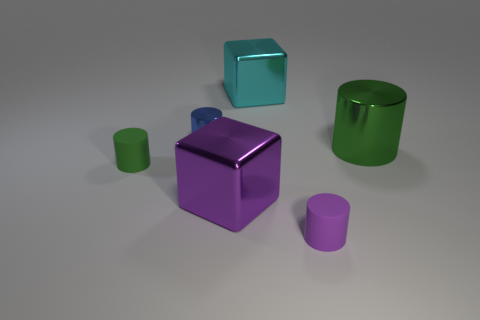Subtract 1 cylinders. How many cylinders are left? 3 Add 2 big cyan cubes. How many objects exist? 8 Subtract all cylinders. How many objects are left? 2 Subtract all matte objects. Subtract all big blue matte cylinders. How many objects are left? 4 Add 6 purple rubber cylinders. How many purple rubber cylinders are left? 7 Add 1 cubes. How many cubes exist? 3 Subtract 0 purple balls. How many objects are left? 6 